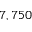<formula> <loc_0><loc_0><loc_500><loc_500>7 , 7 5 0</formula> 